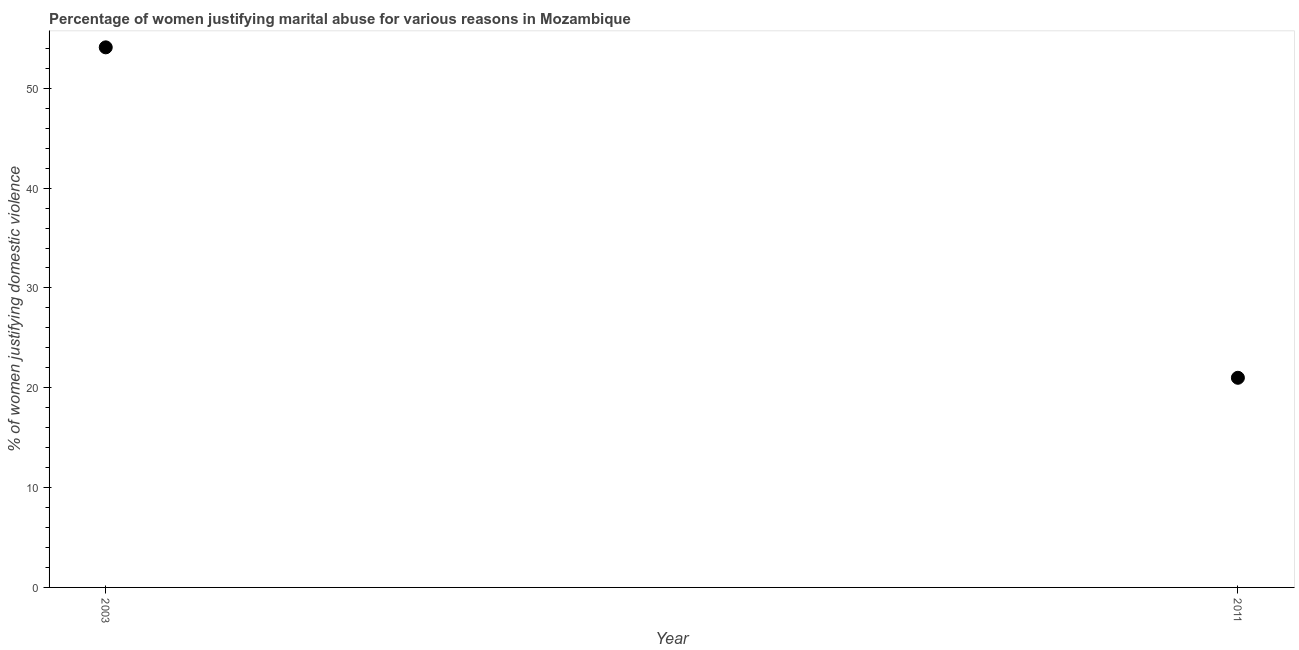Across all years, what is the maximum percentage of women justifying marital abuse?
Your response must be concise. 54.1. In which year was the percentage of women justifying marital abuse maximum?
Make the answer very short. 2003. What is the sum of the percentage of women justifying marital abuse?
Your answer should be very brief. 75.1. What is the difference between the percentage of women justifying marital abuse in 2003 and 2011?
Offer a terse response. 33.1. What is the average percentage of women justifying marital abuse per year?
Provide a succinct answer. 37.55. What is the median percentage of women justifying marital abuse?
Your answer should be very brief. 37.55. In how many years, is the percentage of women justifying marital abuse greater than 2 %?
Provide a short and direct response. 2. What is the ratio of the percentage of women justifying marital abuse in 2003 to that in 2011?
Offer a terse response. 2.58. How many years are there in the graph?
Give a very brief answer. 2. What is the difference between two consecutive major ticks on the Y-axis?
Make the answer very short. 10. Does the graph contain any zero values?
Your answer should be compact. No. Does the graph contain grids?
Offer a terse response. No. What is the title of the graph?
Provide a succinct answer. Percentage of women justifying marital abuse for various reasons in Mozambique. What is the label or title of the X-axis?
Keep it short and to the point. Year. What is the label or title of the Y-axis?
Your answer should be very brief. % of women justifying domestic violence. What is the % of women justifying domestic violence in 2003?
Offer a terse response. 54.1. What is the difference between the % of women justifying domestic violence in 2003 and 2011?
Keep it short and to the point. 33.1. What is the ratio of the % of women justifying domestic violence in 2003 to that in 2011?
Your answer should be very brief. 2.58. 